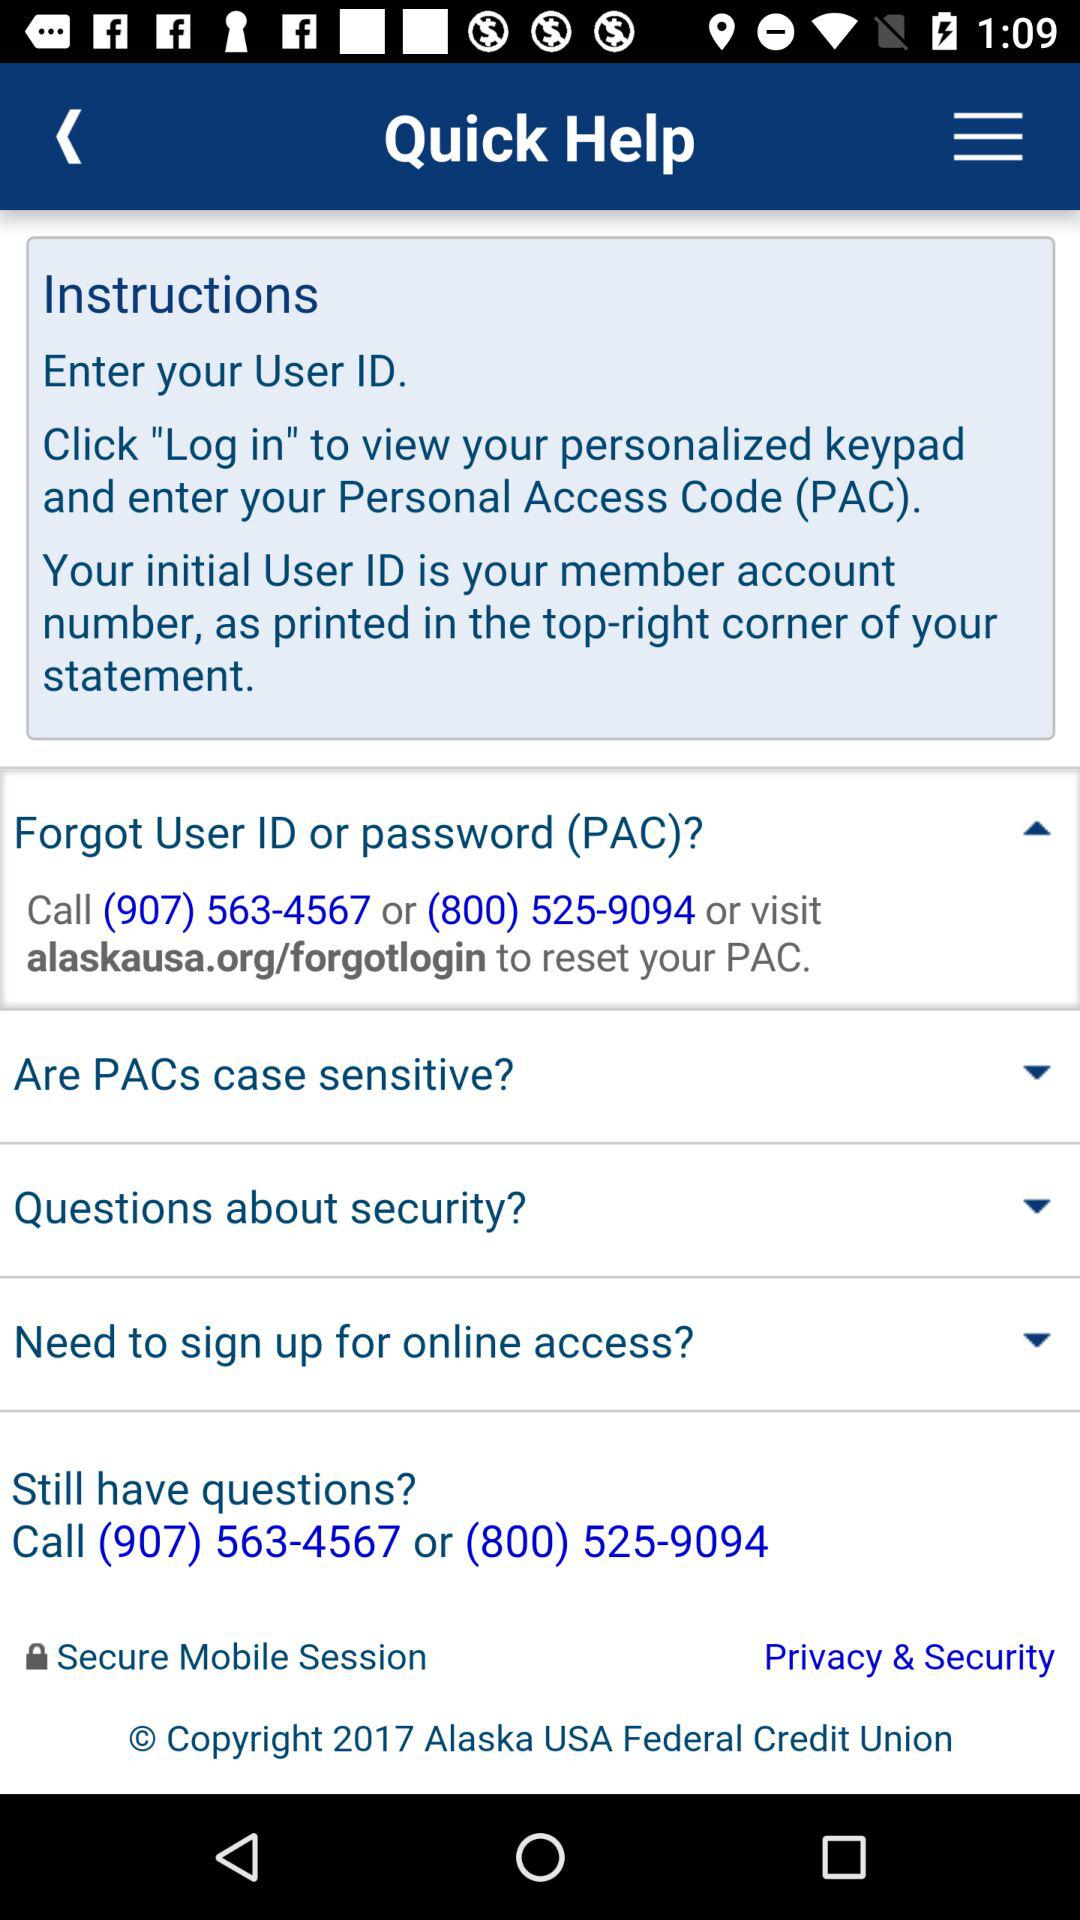What is the contact number? The contact numbers are (907) 563-4567 and (800) 525-9094. 